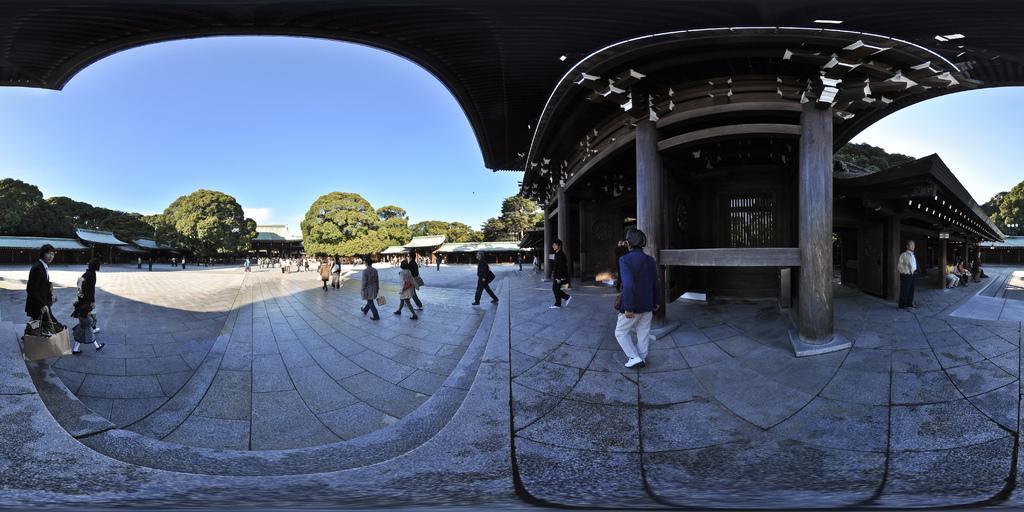How would you summarize this image in a sentence or two? In this image there is the sky, there are trees, there are buildings, there are group of persons walking, there are persons holding an object, there are group of persons sitting, there are two men standing towards the right of the image, there are pillars, there is the roof towards the top of the image. 